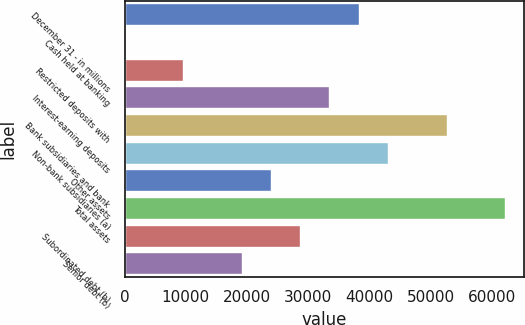Convert chart to OTSL. <chart><loc_0><loc_0><loc_500><loc_500><bar_chart><fcel>December 31 - in millions<fcel>Cash held at banking<fcel>Restricted deposits with<fcel>Interest-earning deposits<fcel>Bank subsidiaries and bank<fcel>Non-bank subsidiaries (a)<fcel>Other assets<fcel>Total assets<fcel>Subordinated debt (b)<fcel>Senior debt (b)<nl><fcel>38264.2<fcel>1<fcel>9566.8<fcel>33481.3<fcel>52612.9<fcel>43047.1<fcel>23915.5<fcel>62178.7<fcel>28698.4<fcel>19132.6<nl></chart> 